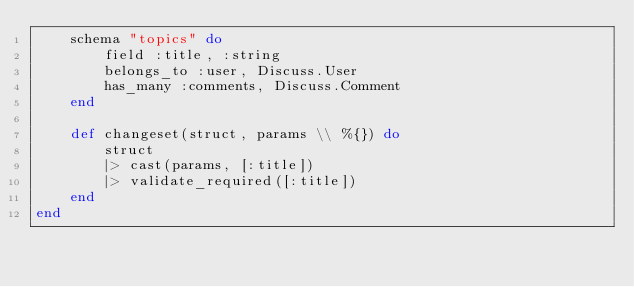<code> <loc_0><loc_0><loc_500><loc_500><_Elixir_>    schema "topics" do
        field :title, :string
        belongs_to :user, Discuss.User
        has_many :comments, Discuss.Comment
    end

    def changeset(struct, params \\ %{}) do
        struct
        |> cast(params, [:title]) 
        |> validate_required([:title])
    end
end</code> 